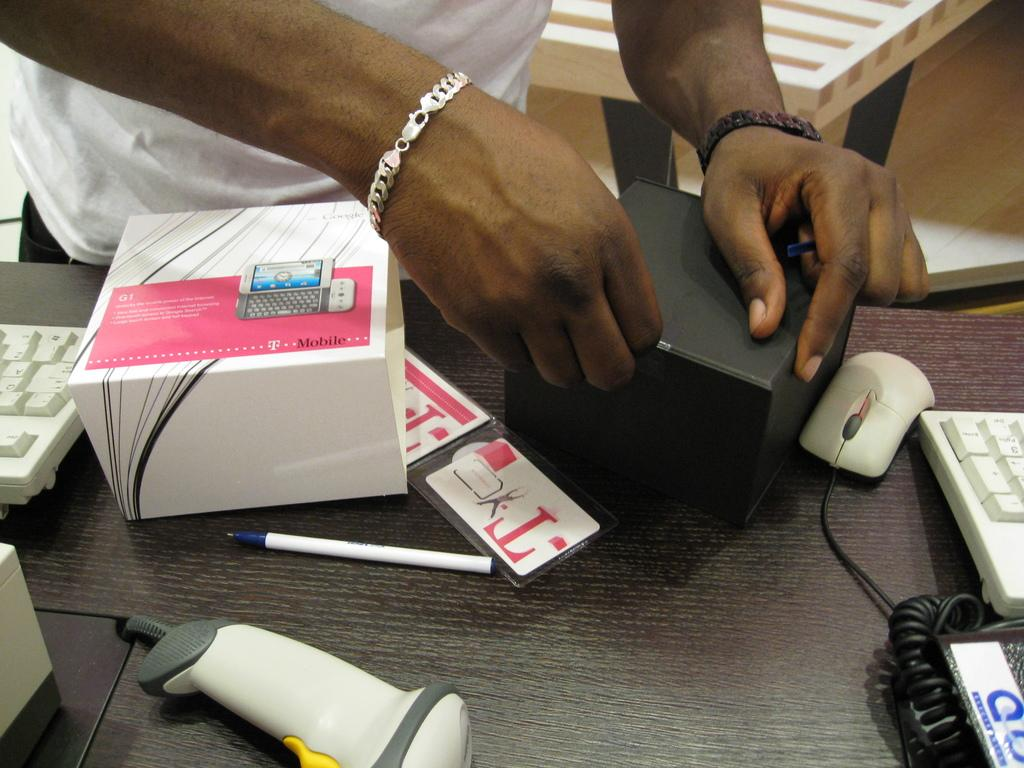What part of a person can be seen in the image? There is a person's hand in the image. How many boxes are visible in the image? There are two boxes in the image. What writing instrument is present in the image? There is a pen in the image. What type of input device is in the image? There is a mouse in the image. How many keyboards are visible in the image? There are two keyboards in the image. What can be inferred about the person's clothing from the image? The person is wearing a white t-shirt. What type of jam is being spread on the scarf in the image? There is no jam or scarf present in the image. How many screws are visible on the table in the image? There is no mention of screws in the image; only a hand, two boxes, a pen, a mouse, two keyboards, and unspecified objects on the table are mentioned. 